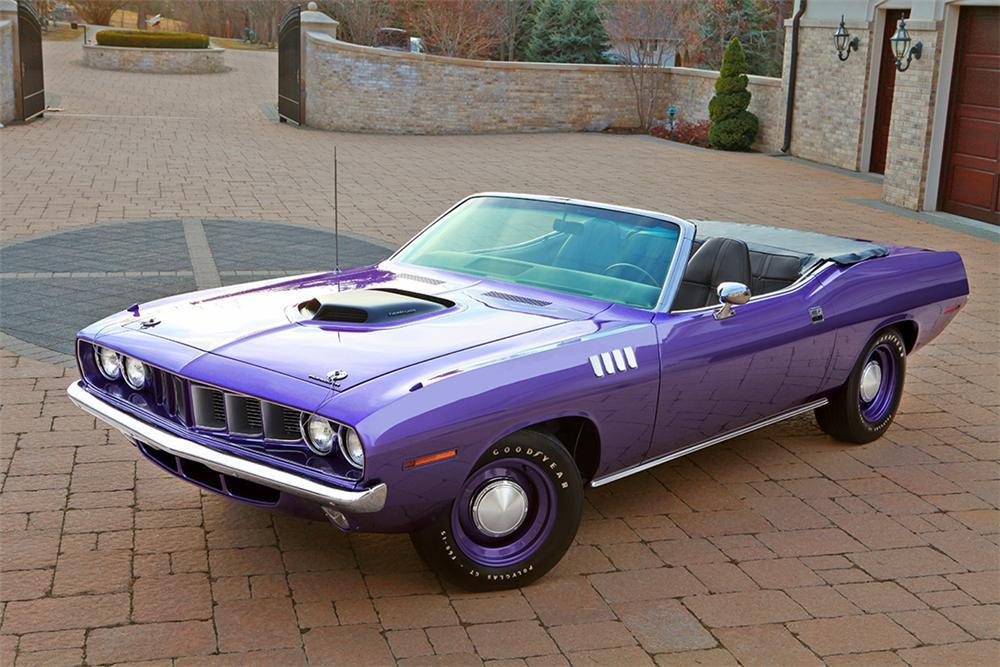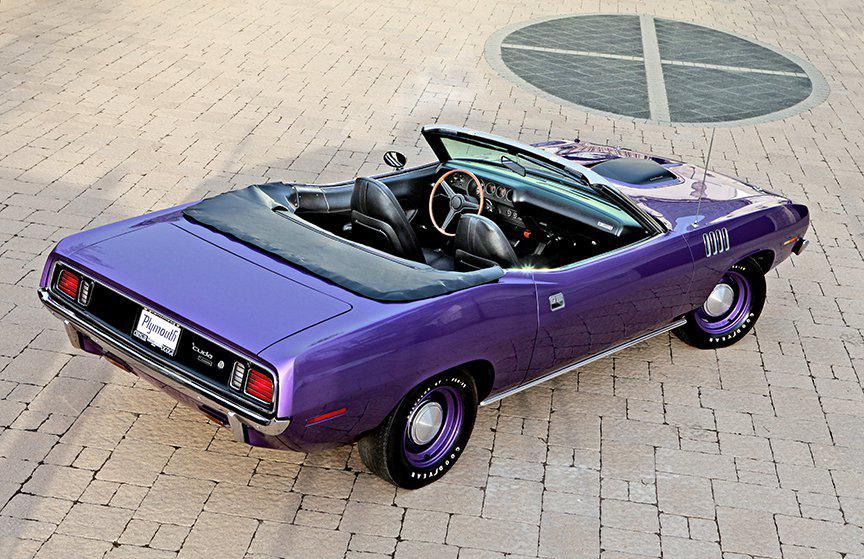The first image is the image on the left, the second image is the image on the right. For the images shown, is this caption "The car in the image on the right is parked near the green grass." true? Answer yes or no. No. 